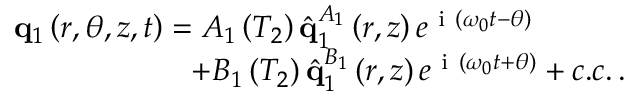<formula> <loc_0><loc_0><loc_500><loc_500>\begin{array} { r } { q _ { 1 } \left ( r , \theta , z , t \right ) = A _ { 1 } \left ( T _ { 2 } \right ) \hat { q } _ { 1 } ^ { A _ { 1 } } \left ( r , z \right ) e ^ { i \left ( \omega _ { 0 } t - \theta \right ) } \quad \ } \\ { + B _ { 1 } \left ( T _ { 2 } \right ) \hat { q } _ { 1 } ^ { B _ { 1 } } \left ( r , z \right ) e ^ { i \left ( \omega _ { 0 } t + \theta \right ) } + c . c . \, . } \end{array}</formula> 